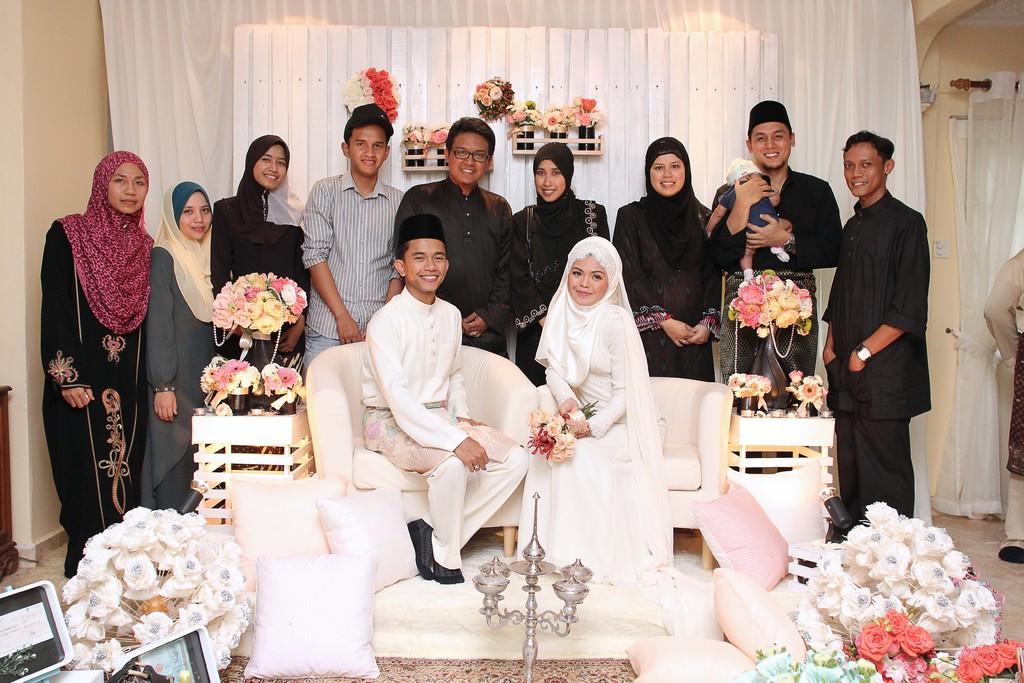Describe this image in one or two sentences. In this picture I can see two people are sitting on the chairs, few people are standing behind, around I can see some flowers. 